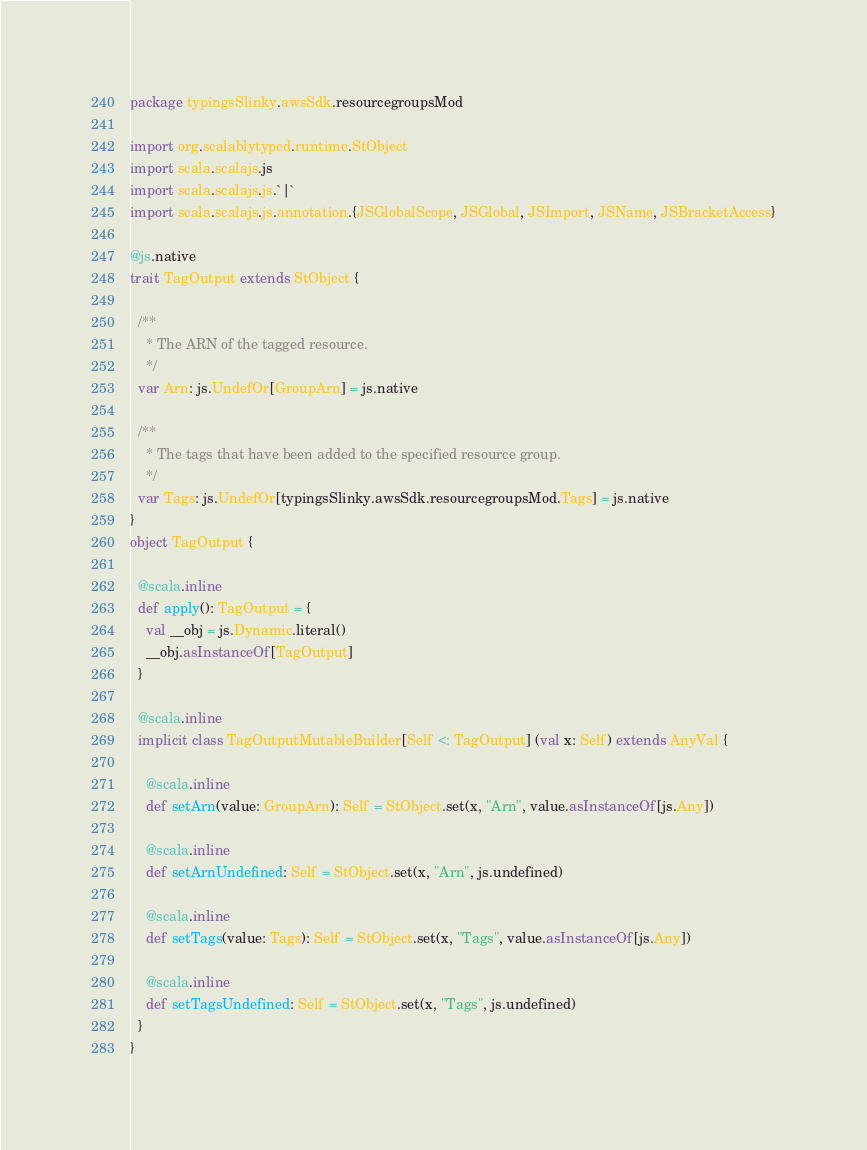<code> <loc_0><loc_0><loc_500><loc_500><_Scala_>package typingsSlinky.awsSdk.resourcegroupsMod

import org.scalablytyped.runtime.StObject
import scala.scalajs.js
import scala.scalajs.js.`|`
import scala.scalajs.js.annotation.{JSGlobalScope, JSGlobal, JSImport, JSName, JSBracketAccess}

@js.native
trait TagOutput extends StObject {
  
  /**
    * The ARN of the tagged resource.
    */
  var Arn: js.UndefOr[GroupArn] = js.native
  
  /**
    * The tags that have been added to the specified resource group.
    */
  var Tags: js.UndefOr[typingsSlinky.awsSdk.resourcegroupsMod.Tags] = js.native
}
object TagOutput {
  
  @scala.inline
  def apply(): TagOutput = {
    val __obj = js.Dynamic.literal()
    __obj.asInstanceOf[TagOutput]
  }
  
  @scala.inline
  implicit class TagOutputMutableBuilder[Self <: TagOutput] (val x: Self) extends AnyVal {
    
    @scala.inline
    def setArn(value: GroupArn): Self = StObject.set(x, "Arn", value.asInstanceOf[js.Any])
    
    @scala.inline
    def setArnUndefined: Self = StObject.set(x, "Arn", js.undefined)
    
    @scala.inline
    def setTags(value: Tags): Self = StObject.set(x, "Tags", value.asInstanceOf[js.Any])
    
    @scala.inline
    def setTagsUndefined: Self = StObject.set(x, "Tags", js.undefined)
  }
}
</code> 